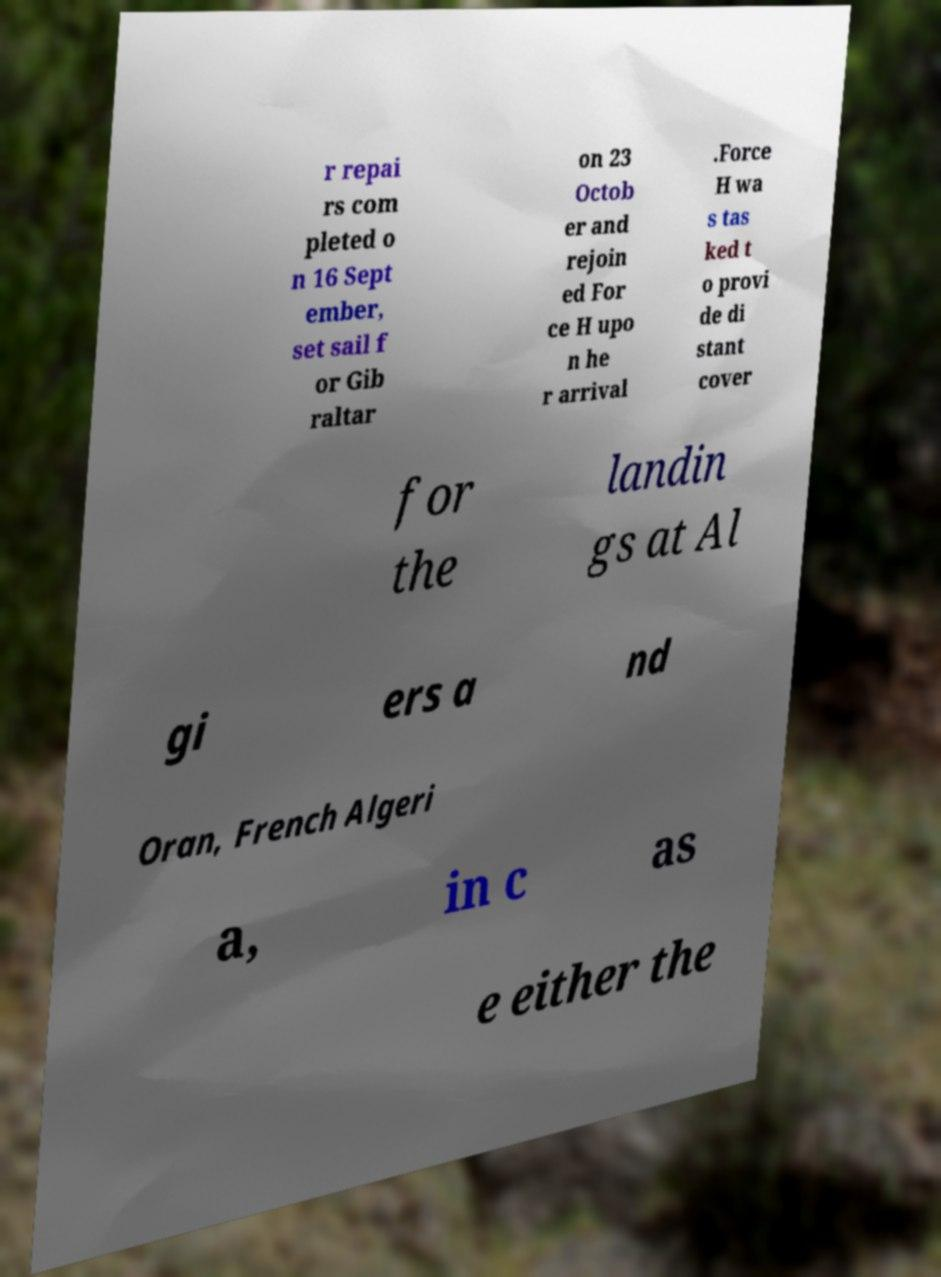There's text embedded in this image that I need extracted. Can you transcribe it verbatim? r repai rs com pleted o n 16 Sept ember, set sail f or Gib raltar on 23 Octob er and rejoin ed For ce H upo n he r arrival .Force H wa s tas ked t o provi de di stant cover for the landin gs at Al gi ers a nd Oran, French Algeri a, in c as e either the 